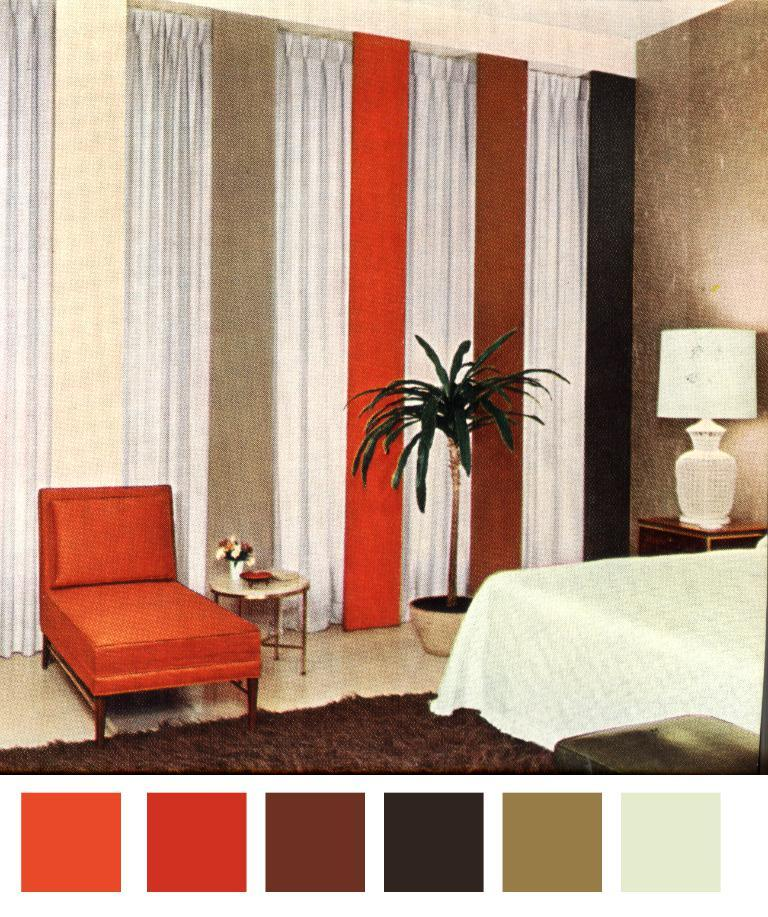What is the main object in the image? There is a color chart in the image. What type of furniture can be seen in the image? A: There is a bed, a lamp, a plant, a curtain, a wall, a couch, and a floor mat visible in the image. What is the flooring material in the image? There is a floor visible in the image. What type of cable is being used to hold up the plant in the image? There is no cable visible in the image; the plant is not being held up by any cable. Can you see any chalk drawings on the floor in the image? There is no chalk or chalk drawings present in the image. 